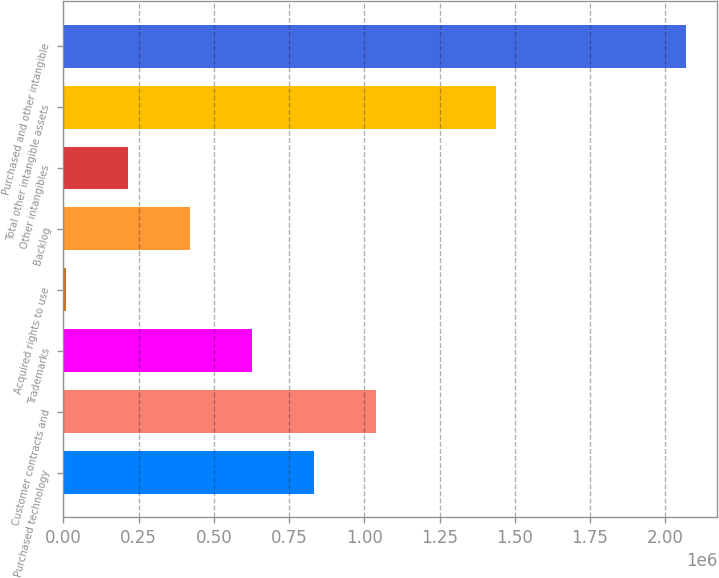Convert chart. <chart><loc_0><loc_0><loc_500><loc_500><bar_chart><fcel>Purchased technology<fcel>Customer contracts and<fcel>Trademarks<fcel>Acquired rights to use<fcel>Backlog<fcel>Other intangibles<fcel>Total other intangible assets<fcel>Purchased and other intangible<nl><fcel>833718<fcel>1.0396e+06<fcel>627838<fcel>10196<fcel>421957<fcel>216076<fcel>1.43753e+06<fcel>2.069e+06<nl></chart> 